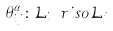Convert formula to latex. <formula><loc_0><loc_0><loc_500><loc_500>\theta _ { i j } ^ { \alpha } \colon \mathcal { L } _ { i } \ r i s o \mathcal { L } _ { j }</formula> 